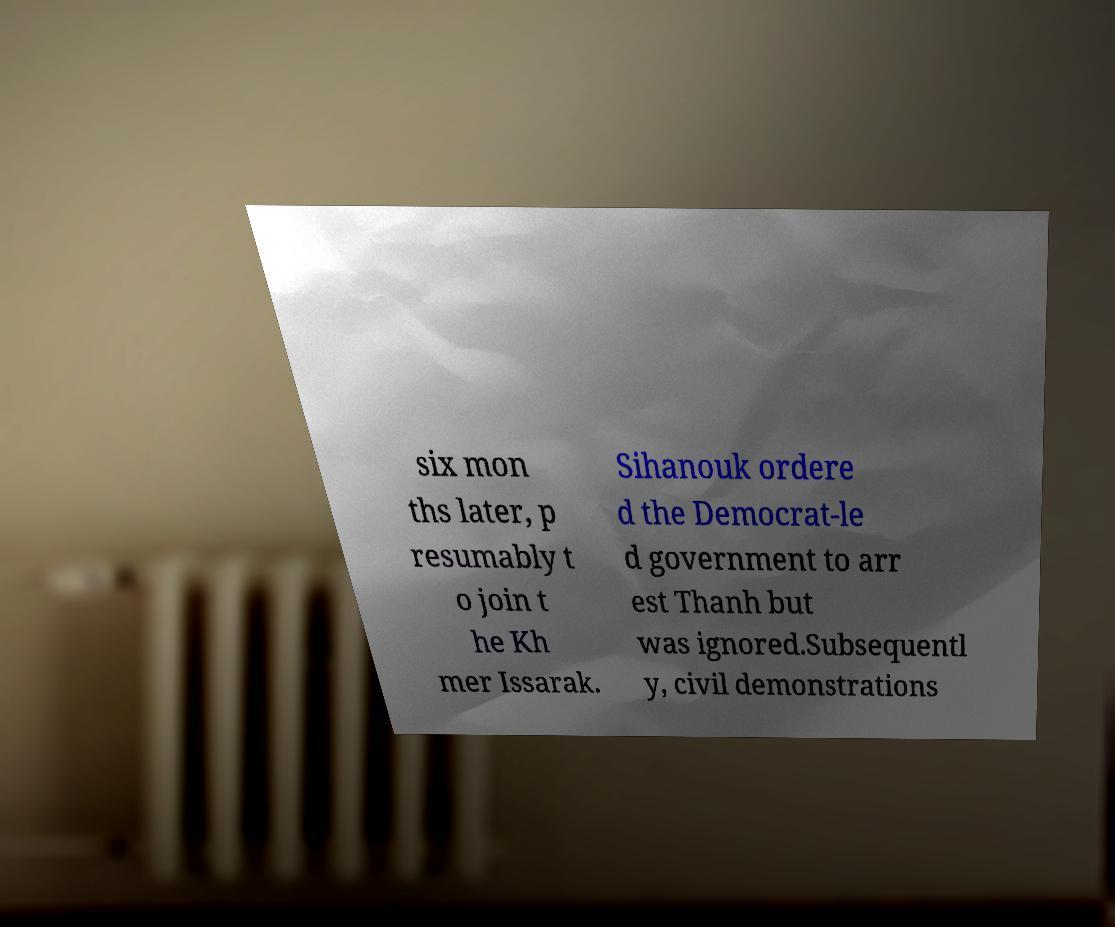Could you extract and type out the text from this image? six mon ths later, p resumably t o join t he Kh mer Issarak. Sihanouk ordere d the Democrat-le d government to arr est Thanh but was ignored.Subsequentl y, civil demonstrations 